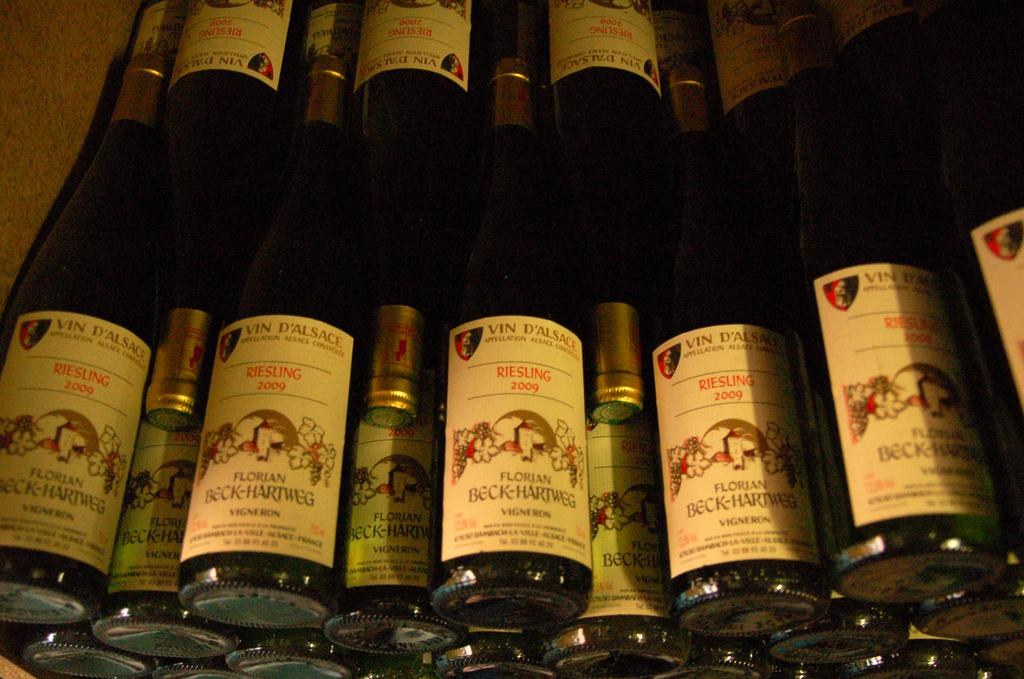<image>
Write a terse but informative summary of the picture. Bottles of alcohol with a label that says "Florian Beck-Hartweg". 